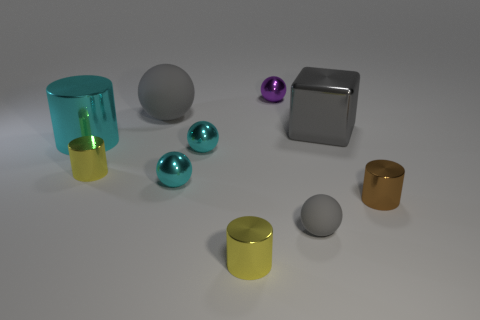Subtract all small metal cylinders. How many cylinders are left? 1 Subtract all brown cylinders. How many cyan spheres are left? 2 Subtract all blocks. How many objects are left? 9 Subtract all cyan cylinders. How many cylinders are left? 3 Subtract all green cylinders. Subtract all gray cubes. How many cylinders are left? 4 Add 5 gray spheres. How many gray spheres are left? 7 Add 4 big brown shiny things. How many big brown shiny things exist? 4 Subtract 0 blue cylinders. How many objects are left? 10 Subtract 4 balls. How many balls are left? 1 Subtract all large cyan cylinders. Subtract all tiny gray objects. How many objects are left? 8 